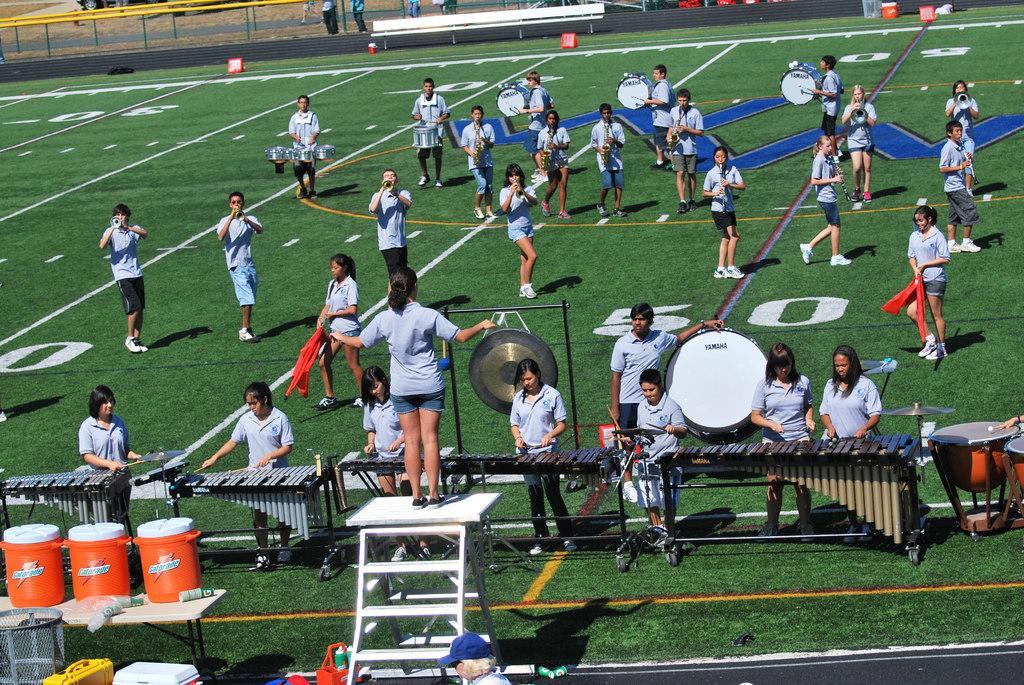Describe this image in one or two sentences. In this image I can see number of people are standing, I can also see all of them are holding musical instrument. Here I can see a ladder and in the background I can see few more people and a bench. 